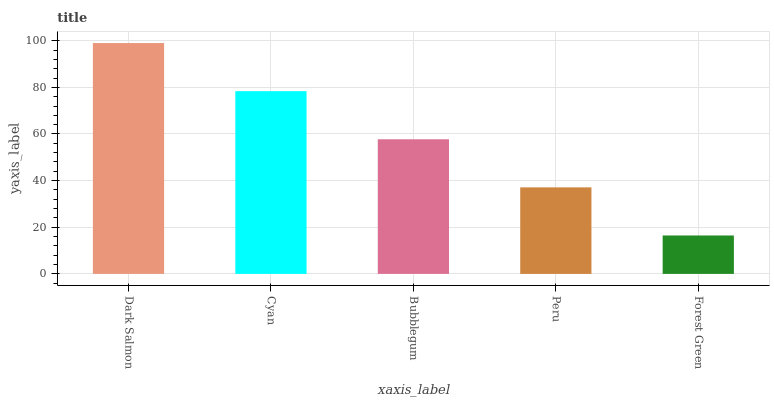Is Forest Green the minimum?
Answer yes or no. Yes. Is Dark Salmon the maximum?
Answer yes or no. Yes. Is Cyan the minimum?
Answer yes or no. No. Is Cyan the maximum?
Answer yes or no. No. Is Dark Salmon greater than Cyan?
Answer yes or no. Yes. Is Cyan less than Dark Salmon?
Answer yes or no. Yes. Is Cyan greater than Dark Salmon?
Answer yes or no. No. Is Dark Salmon less than Cyan?
Answer yes or no. No. Is Bubblegum the high median?
Answer yes or no. Yes. Is Bubblegum the low median?
Answer yes or no. Yes. Is Peru the high median?
Answer yes or no. No. Is Forest Green the low median?
Answer yes or no. No. 